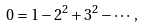<formula> <loc_0><loc_0><loc_500><loc_500>0 = 1 - 2 ^ { 2 } + 3 ^ { 2 } - \cdots \, ,</formula> 